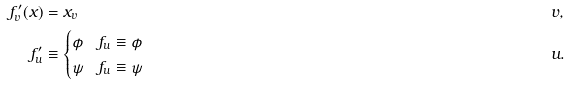<formula> <loc_0><loc_0><loc_500><loc_500>f ^ { \prime } _ { v } ( x ) & = x _ { v } & & v , \\ f ^ { \prime } _ { u } & \equiv \begin{cases} \phi & f _ { u } \equiv \phi \\ \psi & f _ { u } \equiv \psi \end{cases} & & u .</formula> 